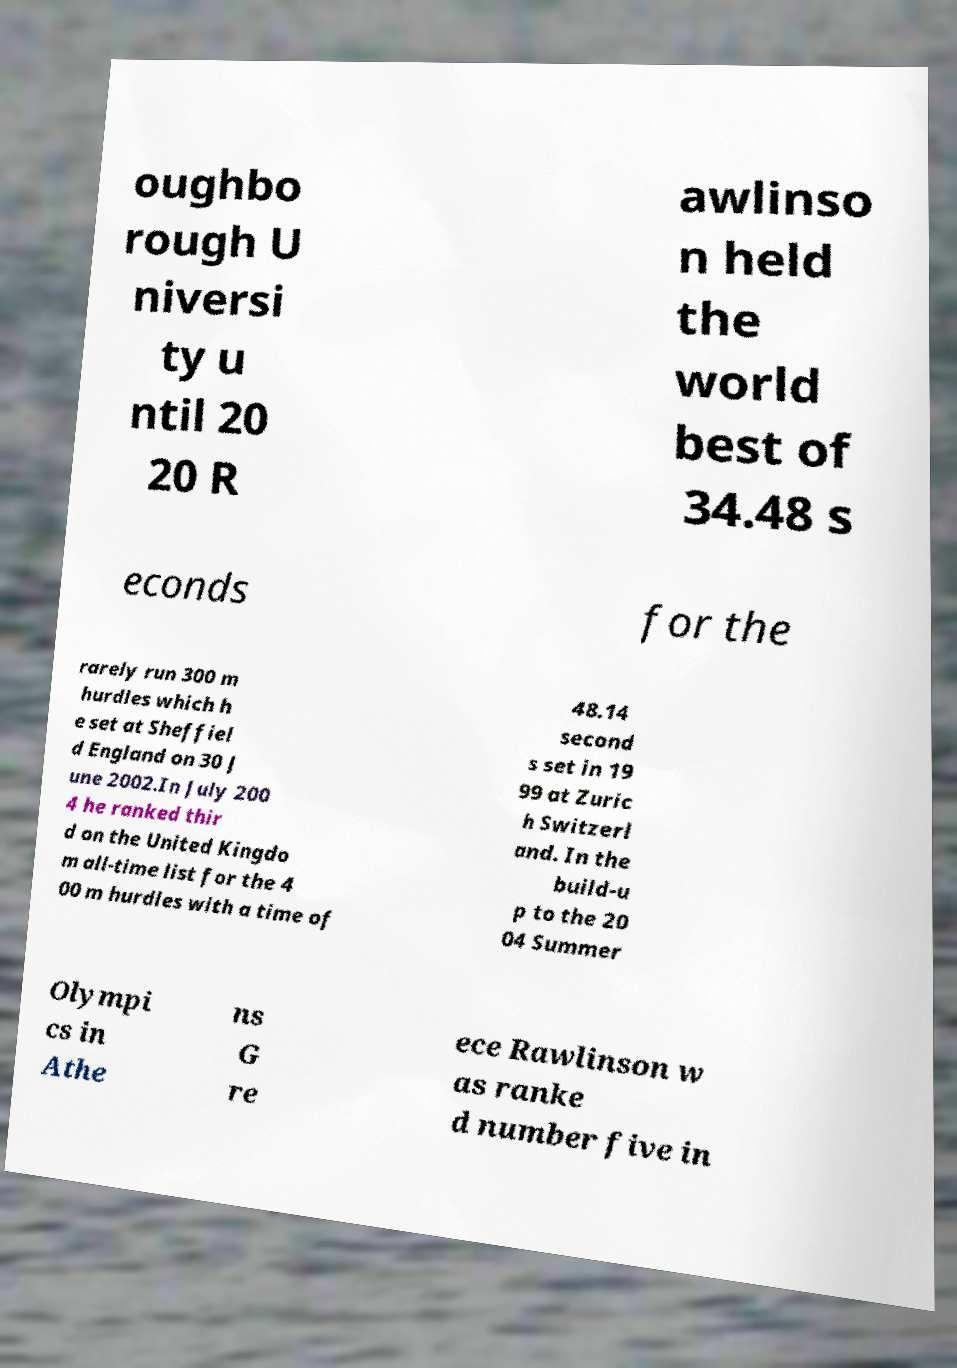Please read and relay the text visible in this image. What does it say? oughbo rough U niversi ty u ntil 20 20 R awlinso n held the world best of 34.48 s econds for the rarely run 300 m hurdles which h e set at Sheffiel d England on 30 J une 2002.In July 200 4 he ranked thir d on the United Kingdo m all-time list for the 4 00 m hurdles with a time of 48.14 second s set in 19 99 at Zuric h Switzerl and. In the build-u p to the 20 04 Summer Olympi cs in Athe ns G re ece Rawlinson w as ranke d number five in 